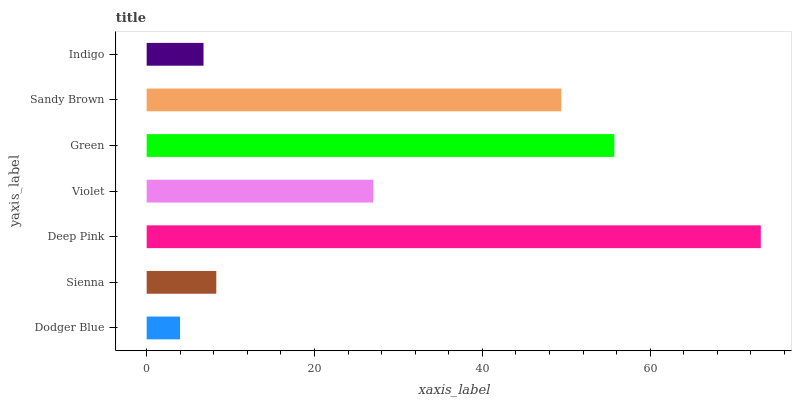Is Dodger Blue the minimum?
Answer yes or no. Yes. Is Deep Pink the maximum?
Answer yes or no. Yes. Is Sienna the minimum?
Answer yes or no. No. Is Sienna the maximum?
Answer yes or no. No. Is Sienna greater than Dodger Blue?
Answer yes or no. Yes. Is Dodger Blue less than Sienna?
Answer yes or no. Yes. Is Dodger Blue greater than Sienna?
Answer yes or no. No. Is Sienna less than Dodger Blue?
Answer yes or no. No. Is Violet the high median?
Answer yes or no. Yes. Is Violet the low median?
Answer yes or no. Yes. Is Sandy Brown the high median?
Answer yes or no. No. Is Deep Pink the low median?
Answer yes or no. No. 